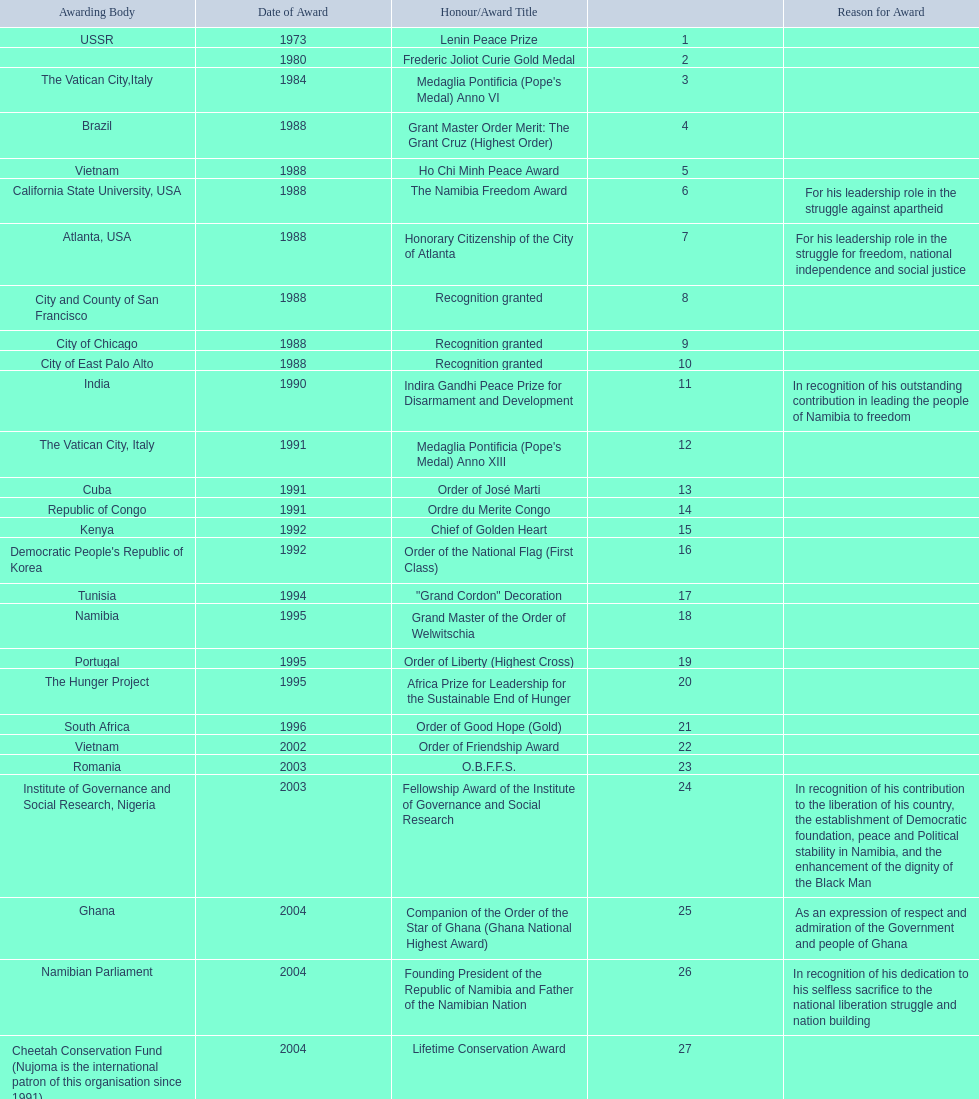What was the name of the honor/award title given after the international kim il sung prize certificate? Sir Seretse Khama SADC Meda. 